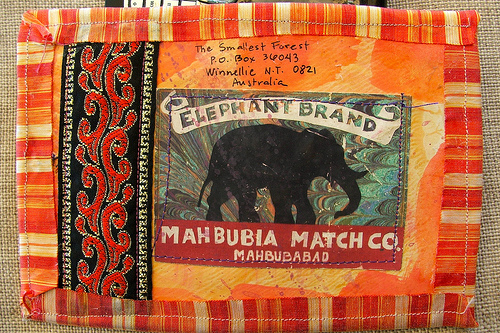<image>
Is the elephant under the address? Yes. The elephant is positioned underneath the address, with the address above it in the vertical space. 